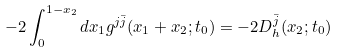Convert formula to latex. <formula><loc_0><loc_0><loc_500><loc_500>- 2 \int _ { 0 } ^ { 1 - x _ { 2 } } d x _ { 1 } g ^ { j \bar { j } } ( x _ { 1 } + x _ { 2 } ; t _ { 0 } ) = - 2 D _ { h } ^ { \bar { j } } ( x _ { 2 } ; t _ { 0 } )</formula> 